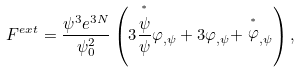Convert formula to latex. <formula><loc_0><loc_0><loc_500><loc_500>F ^ { e x t } = \frac { \psi ^ { 3 } e ^ { 3 N } } { \psi ^ { 2 } _ { 0 } } \left ( 3 \frac { \stackrel { ^ { * } } { \psi } } { \psi } \varphi _ { , \psi } + 3 \varphi _ { , \psi } + \stackrel { ^ { * } } { \varphi } _ { , \psi } \right ) ,</formula> 